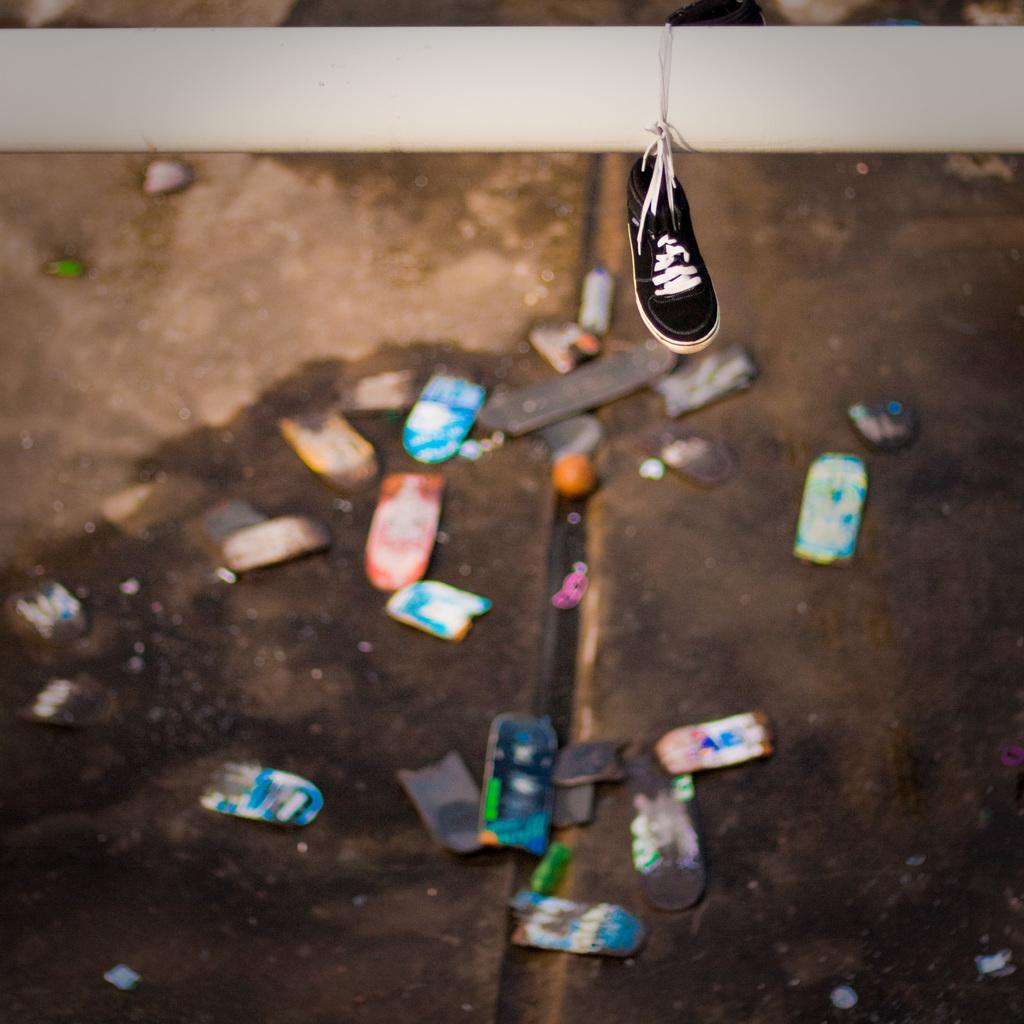What type of shoe is in the image? There is a black shoe in the image. How is the shoe positioned in the image? The shoe is tied to a white pole and hung. What is present on the ground in the image? There is electronic waste on the ground in the image. Can you see a pet sleeping on a bed in the image? No, there is no pet or bed present in the image. Is there any jelly visible in the image? No, there is no jelly present in the image. 